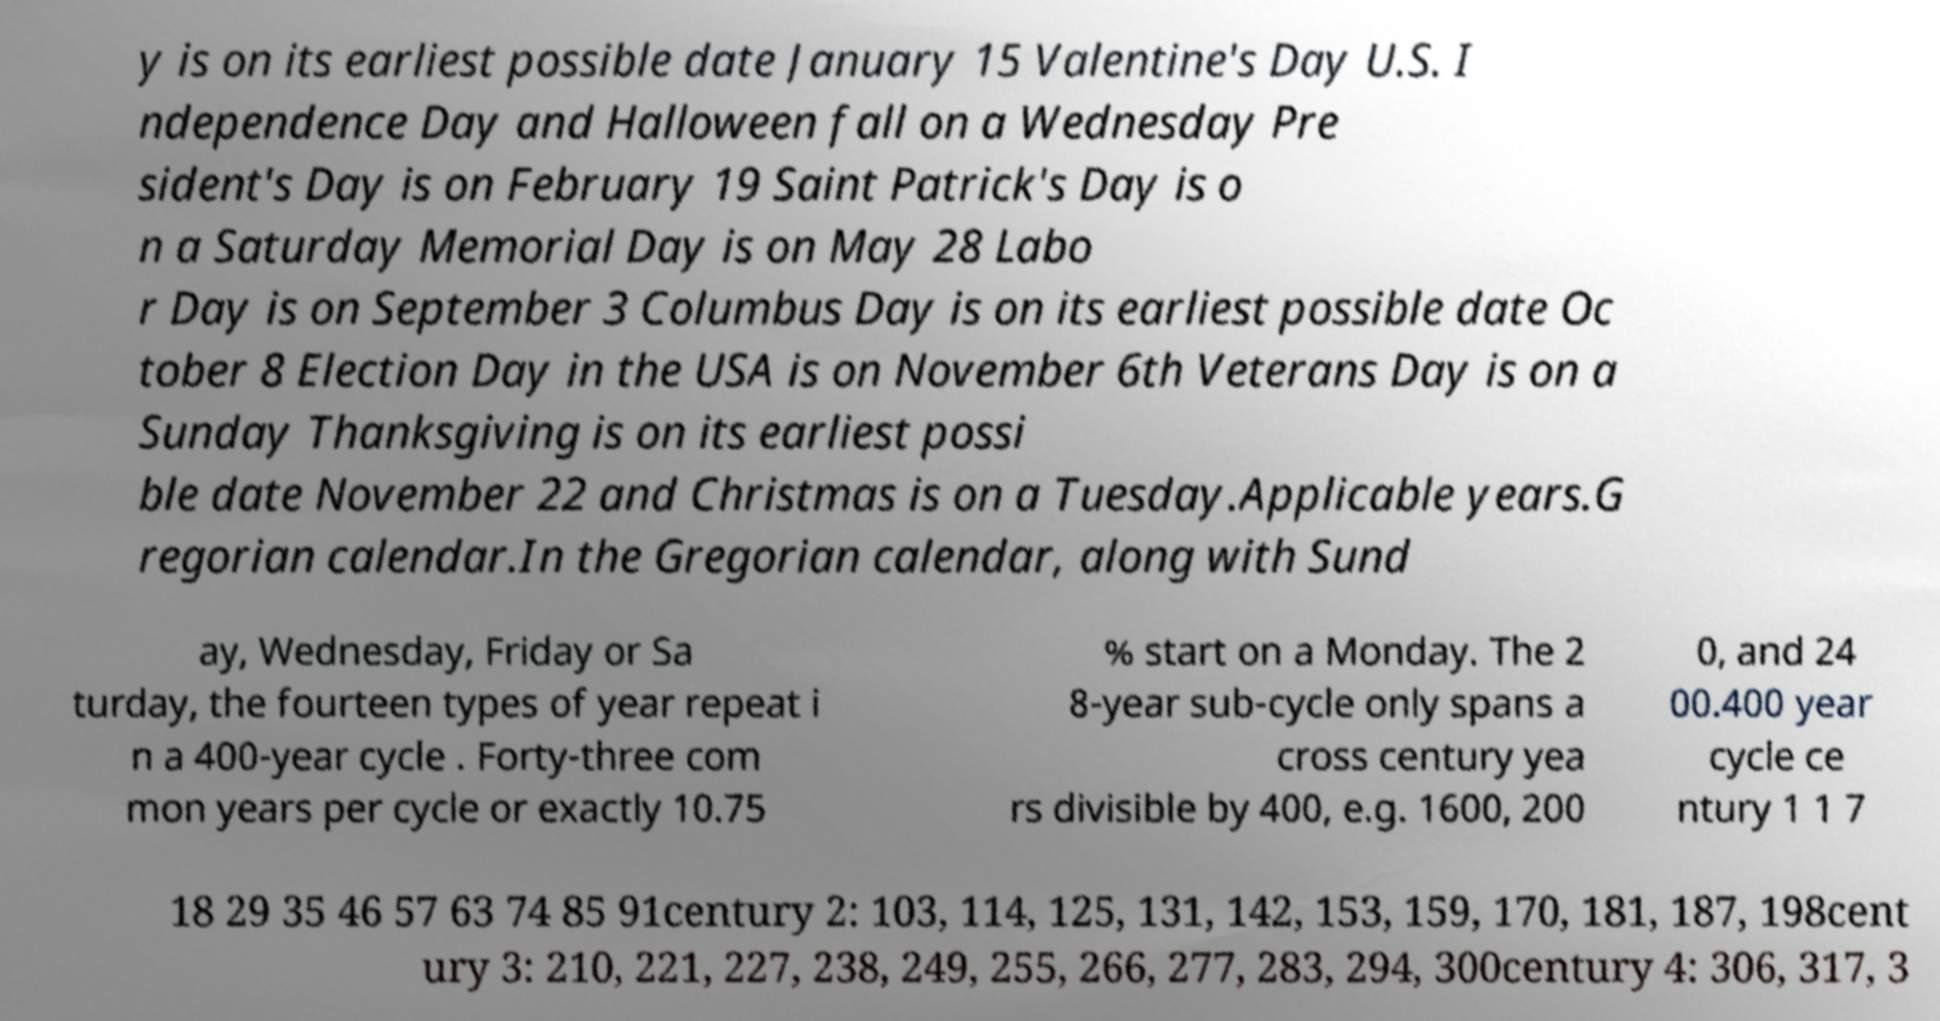Can you accurately transcribe the text from the provided image for me? y is on its earliest possible date January 15 Valentine's Day U.S. I ndependence Day and Halloween fall on a Wednesday Pre sident's Day is on February 19 Saint Patrick's Day is o n a Saturday Memorial Day is on May 28 Labo r Day is on September 3 Columbus Day is on its earliest possible date Oc tober 8 Election Day in the USA is on November 6th Veterans Day is on a Sunday Thanksgiving is on its earliest possi ble date November 22 and Christmas is on a Tuesday.Applicable years.G regorian calendar.In the Gregorian calendar, along with Sund ay, Wednesday, Friday or Sa turday, the fourteen types of year repeat i n a 400-year cycle . Forty-three com mon years per cycle or exactly 10.75 % start on a Monday. The 2 8-year sub-cycle only spans a cross century yea rs divisible by 400, e.g. 1600, 200 0, and 24 00.400 year cycle ce ntury 1 1 7 18 29 35 46 57 63 74 85 91century 2: 103, 114, 125, 131, 142, 153, 159, 170, 181, 187, 198cent ury 3: 210, 221, 227, 238, 249, 255, 266, 277, 283, 294, 300century 4: 306, 317, 3 